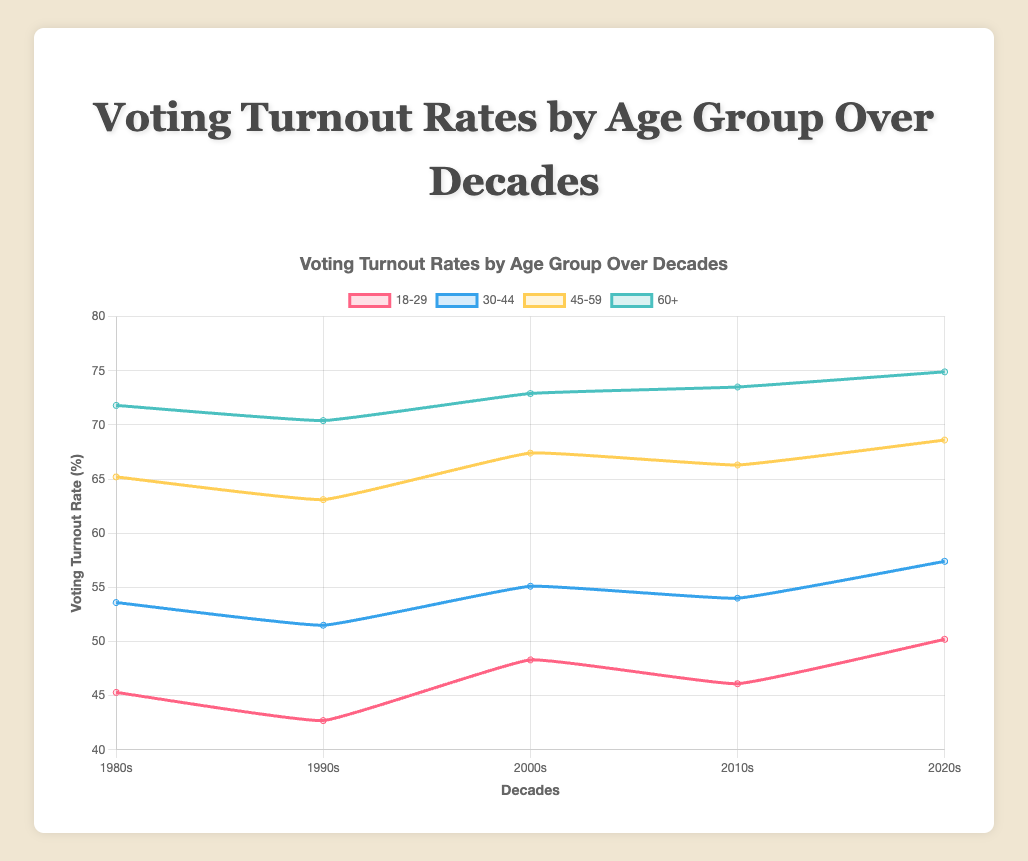What is the overall trend in the voting turnout rate for the 18-29 age group from the 1980s to the 2020s? Examine the plot line representing the 18-29 age group. The trend shows a decrease from the 1980s to the 1990s, followed by an increase through the 2000s, 2010s, and reaching a peak in the 2020s.
Answer: Increasing How much did the voting turnout rate for the 60+ age group increase from the 1980s to the 2020s? Look at the data points for the 60+ age group in the 1980s and the 2020s. Subtract the 1980s value from the 2020s value: 74.9 - 71.8 = 3.1.
Answer: 3.1 Which decade had the lowest voting turnout rate for the 45-59 age group? Check the voting turnout rates for the 45-59 age group across all decades. The lowest value is in the 1990s with 63.1%.
Answer: 1990s What is the difference in voting turnout rates between the 18-29 and 45-59 age groups in the 2020s? Subtract the value of the 18-29 age group from the 45-59 age group in the 2020s: 68.6 - 50.2 = 18.4.
Answer: 18.4 Which age group showed the least variation in voting turnout rates over the provided decades? Calculate the difference between the highest and lowest value for each age group. The 60+ age group has the smallest range (74.9 - 70.4 = 4.5).
Answer: 60+ What is the average voting turnout rate of the 30-44 age group across all decades? Add the values for the 30-44 age group in each decade and divide by the number of decades: (53.6 + 51.5 + 55.1 + 54.0 + 57.4) / 5 = 54.32.
Answer: 54.32 Which age group consistently had the highest voting turnout rate across all decades? Identify which age group's line is on top for all decades. The 60+ age group consistently has the highest voting turnout rates.
Answer: 60+ By how much did the voting turnout rate for the 18-29 age group decrease from the 2000s to the 2010s? Subtract the value of the 18-29 age group in the 2010s from its value in the 2000s: 48.3 - 46.1 = 2.2.
Answer: 2.2 